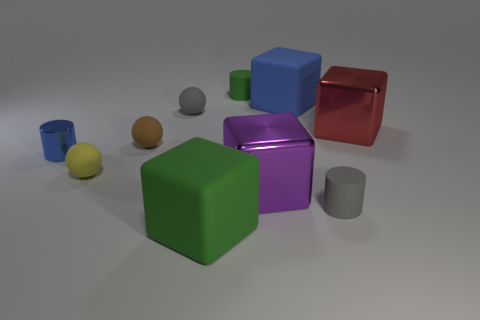Subtract all blocks. How many objects are left? 6 Add 8 tiny brown cylinders. How many tiny brown cylinders exist? 8 Subtract 0 cyan blocks. How many objects are left? 10 Subtract all big blue matte blocks. Subtract all big red cubes. How many objects are left? 8 Add 8 matte blocks. How many matte blocks are left? 10 